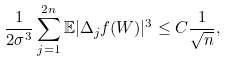Convert formula to latex. <formula><loc_0><loc_0><loc_500><loc_500>\frac { 1 } { 2 \sigma ^ { 3 } } \sum _ { j = 1 } ^ { 2 n } \mathbb { E } | \Delta _ { j } f ( W ) | ^ { 3 } \leq C \frac { 1 } { \sqrt { n } } ,</formula> 